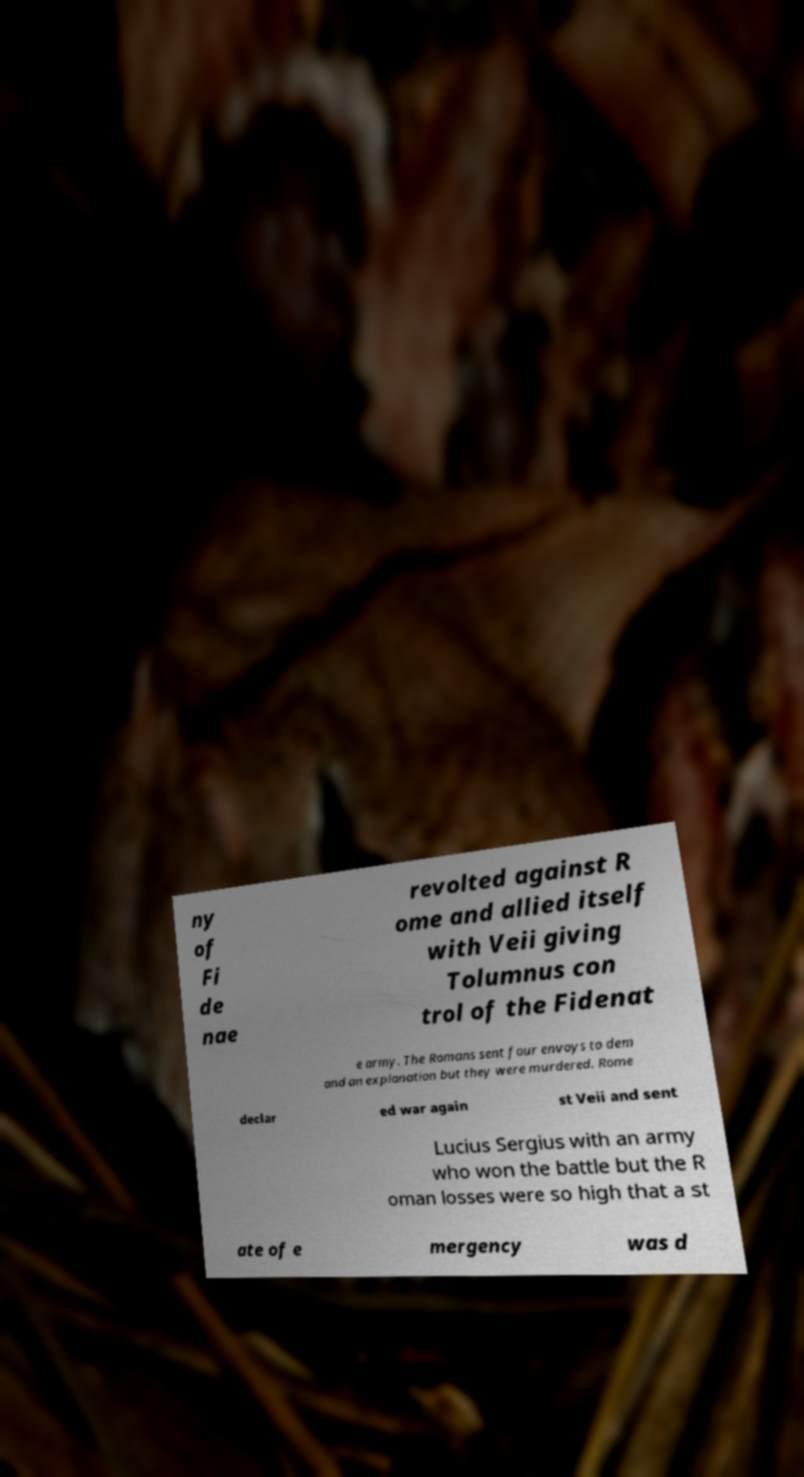Please read and relay the text visible in this image. What does it say? ny of Fi de nae revolted against R ome and allied itself with Veii giving Tolumnus con trol of the Fidenat e army. The Romans sent four envoys to dem and an explanation but they were murdered. Rome declar ed war again st Veii and sent Lucius Sergius with an army who won the battle but the R oman losses were so high that a st ate of e mergency was d 